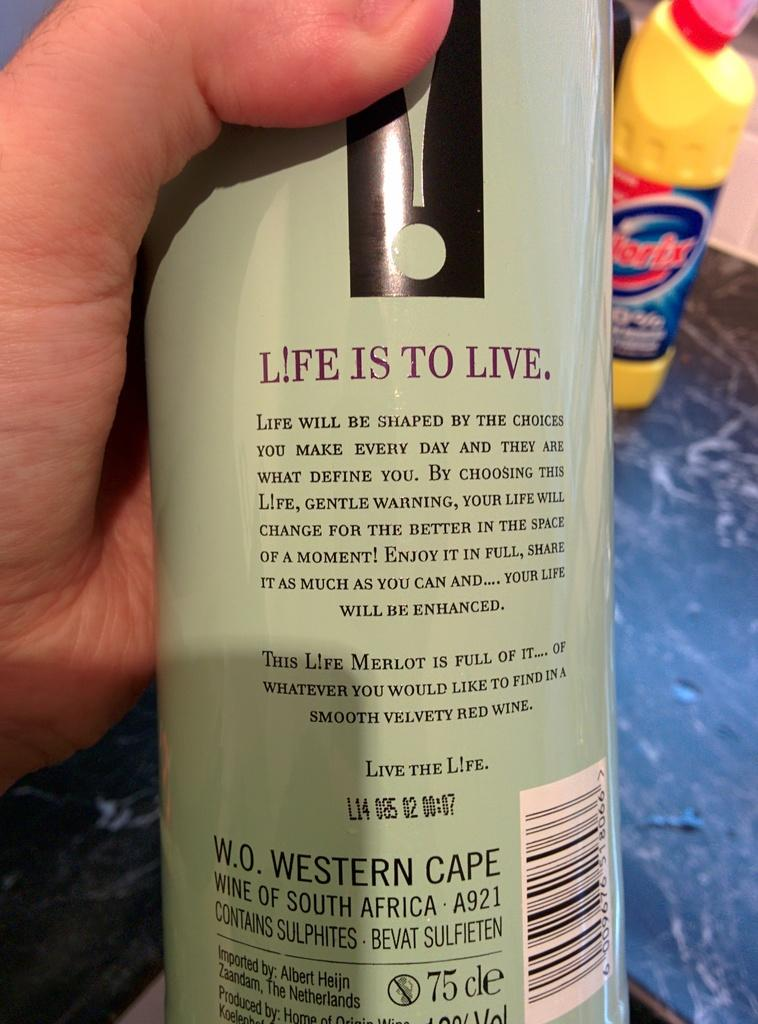<image>
Summarize the visual content of the image. Person holding a bottle that says "Wine of South Africa". 